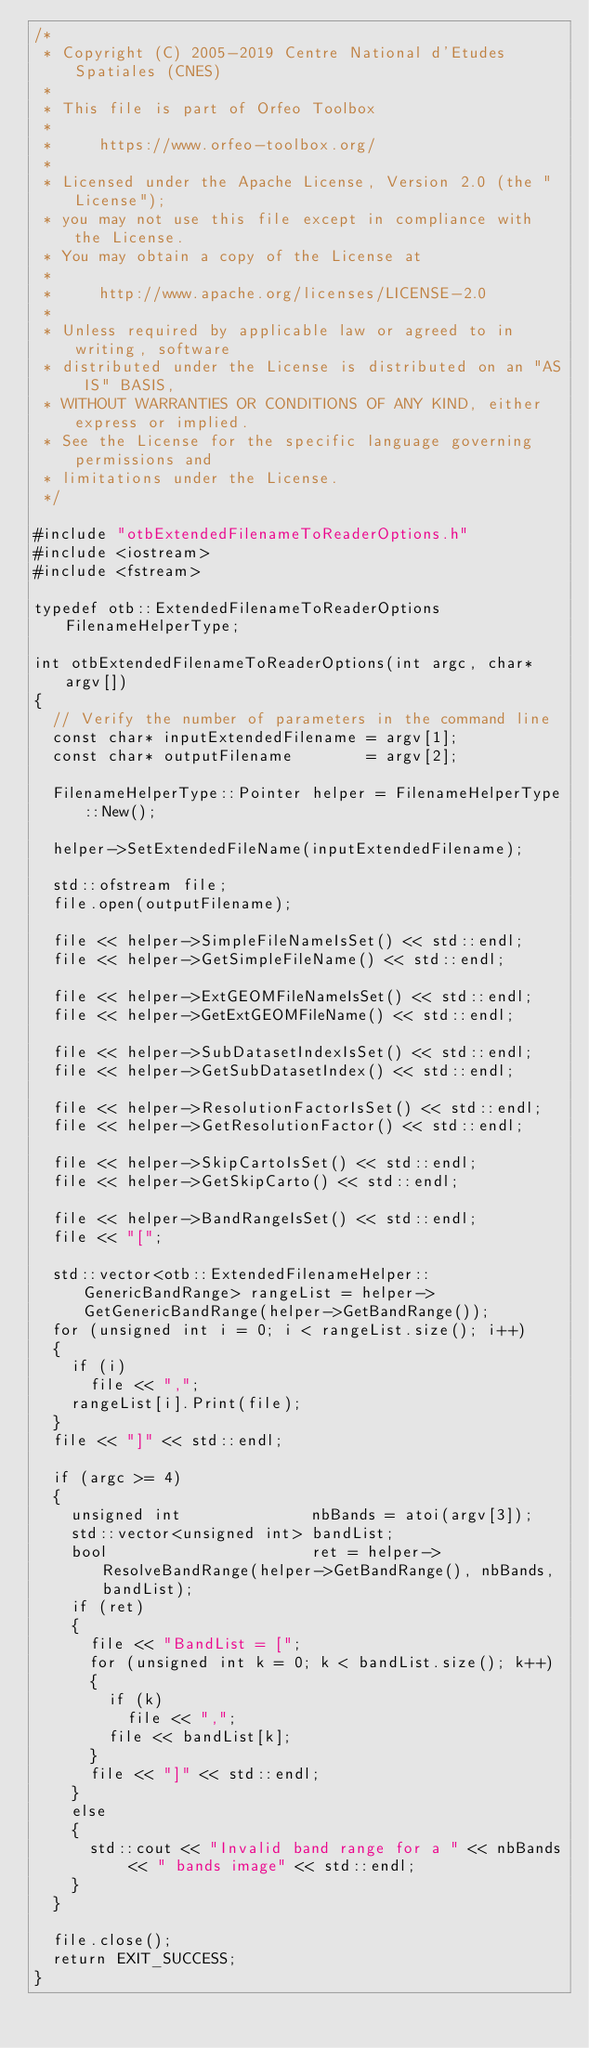<code> <loc_0><loc_0><loc_500><loc_500><_C++_>/*
 * Copyright (C) 2005-2019 Centre National d'Etudes Spatiales (CNES)
 *
 * This file is part of Orfeo Toolbox
 *
 *     https://www.orfeo-toolbox.org/
 *
 * Licensed under the Apache License, Version 2.0 (the "License");
 * you may not use this file except in compliance with the License.
 * You may obtain a copy of the License at
 *
 *     http://www.apache.org/licenses/LICENSE-2.0
 *
 * Unless required by applicable law or agreed to in writing, software
 * distributed under the License is distributed on an "AS IS" BASIS,
 * WITHOUT WARRANTIES OR CONDITIONS OF ANY KIND, either express or implied.
 * See the License for the specific language governing permissions and
 * limitations under the License.
 */

#include "otbExtendedFilenameToReaderOptions.h"
#include <iostream>
#include <fstream>

typedef otb::ExtendedFilenameToReaderOptions FilenameHelperType;

int otbExtendedFilenameToReaderOptions(int argc, char* argv[])
{
  // Verify the number of parameters in the command line
  const char* inputExtendedFilename = argv[1];
  const char* outputFilename        = argv[2];

  FilenameHelperType::Pointer helper = FilenameHelperType::New();

  helper->SetExtendedFileName(inputExtendedFilename);

  std::ofstream file;
  file.open(outputFilename);

  file << helper->SimpleFileNameIsSet() << std::endl;
  file << helper->GetSimpleFileName() << std::endl;

  file << helper->ExtGEOMFileNameIsSet() << std::endl;
  file << helper->GetExtGEOMFileName() << std::endl;

  file << helper->SubDatasetIndexIsSet() << std::endl;
  file << helper->GetSubDatasetIndex() << std::endl;

  file << helper->ResolutionFactorIsSet() << std::endl;
  file << helper->GetResolutionFactor() << std::endl;

  file << helper->SkipCartoIsSet() << std::endl;
  file << helper->GetSkipCarto() << std::endl;

  file << helper->BandRangeIsSet() << std::endl;
  file << "[";

  std::vector<otb::ExtendedFilenameHelper::GenericBandRange> rangeList = helper->GetGenericBandRange(helper->GetBandRange());
  for (unsigned int i = 0; i < rangeList.size(); i++)
  {
    if (i)
      file << ",";
    rangeList[i].Print(file);
  }
  file << "]" << std::endl;

  if (argc >= 4)
  {
    unsigned int              nbBands = atoi(argv[3]);
    std::vector<unsigned int> bandList;
    bool                      ret = helper->ResolveBandRange(helper->GetBandRange(), nbBands, bandList);
    if (ret)
    {
      file << "BandList = [";
      for (unsigned int k = 0; k < bandList.size(); k++)
      {
        if (k)
          file << ",";
        file << bandList[k];
      }
      file << "]" << std::endl;
    }
    else
    {
      std::cout << "Invalid band range for a " << nbBands << " bands image" << std::endl;
    }
  }

  file.close();
  return EXIT_SUCCESS;
}
</code> 